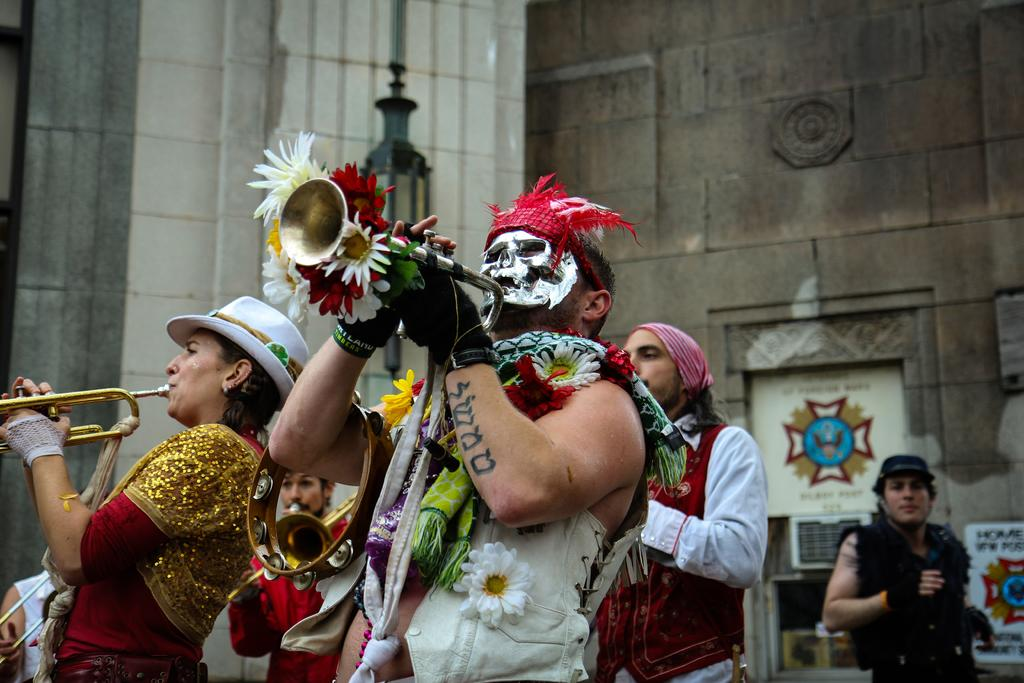What is happening in the image involving the people? Some of the people are playing musical instruments. What else can be seen in the image besides the people? There are flowers, a light pole, and a wall in the image. Are there any dinosaurs visible in the image? No, there are no dinosaurs present in the image. Can you tell me who the achiever is in the image? The provided facts do not mention any specific achiever in the image. 